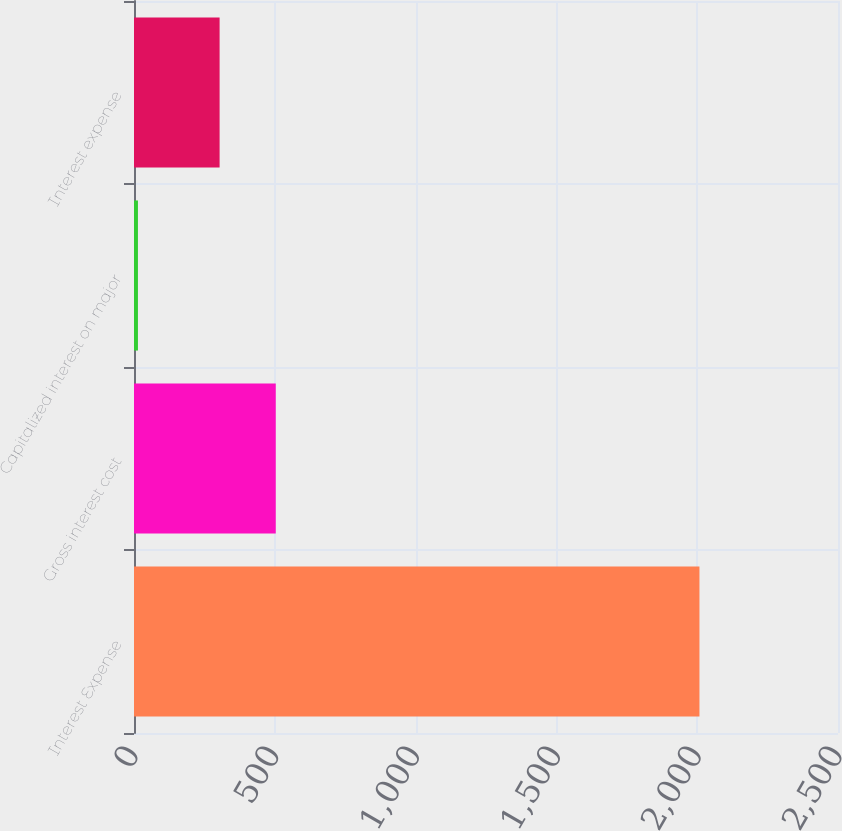<chart> <loc_0><loc_0><loc_500><loc_500><bar_chart><fcel>Interest Expense<fcel>Gross interest cost<fcel>Capitalized interest on major<fcel>Interest expense<nl><fcel>2008<fcel>503.4<fcel>14<fcel>304<nl></chart> 